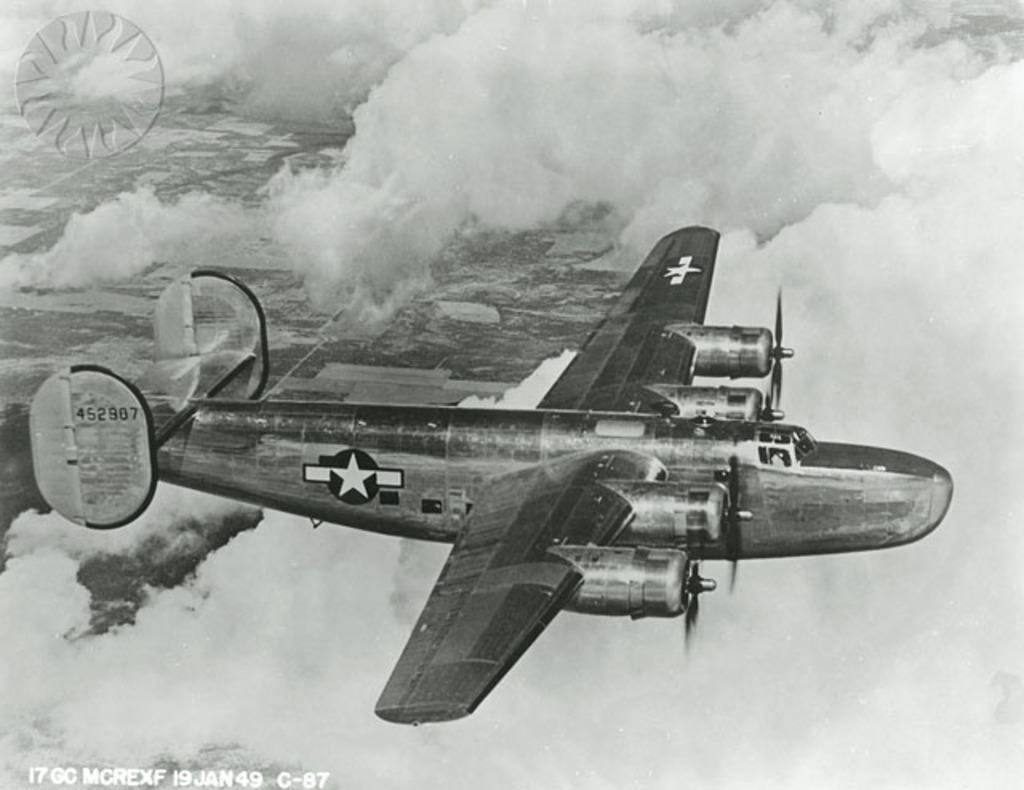What is the color scheme of the image? The image is black and white. What is the main subject of the image? There is an airplane in the image. What is the airplane doing in the image? The airplane is flying in the sky. What can be seen in the sky in the image? There are clouds visible in the image. What type of organization is the girl attending in the image? There is no girl present in the image, and therefore no organization can be associated with her. 